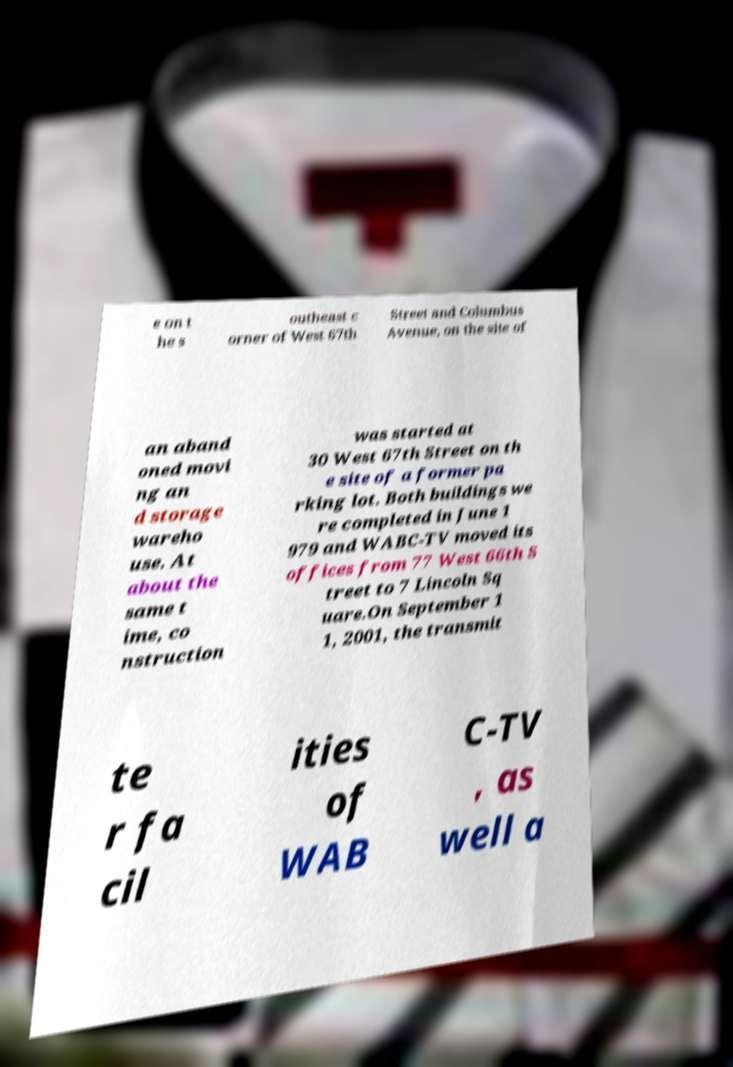There's text embedded in this image that I need extracted. Can you transcribe it verbatim? e on t he s outheast c orner of West 67th Street and Columbus Avenue, on the site of an aband oned movi ng an d storage wareho use. At about the same t ime, co nstruction was started at 30 West 67th Street on th e site of a former pa rking lot. Both buildings we re completed in June 1 979 and WABC-TV moved its offices from 77 West 66th S treet to 7 Lincoln Sq uare.On September 1 1, 2001, the transmit te r fa cil ities of WAB C-TV , as well a 